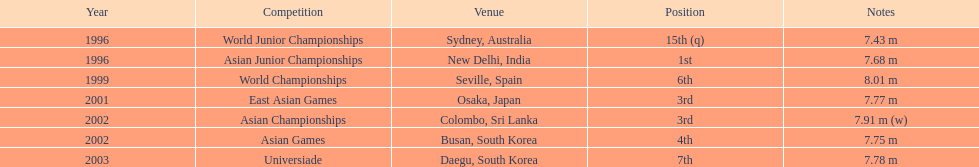When was the 3rd position first reached in a specific year? 2001. 